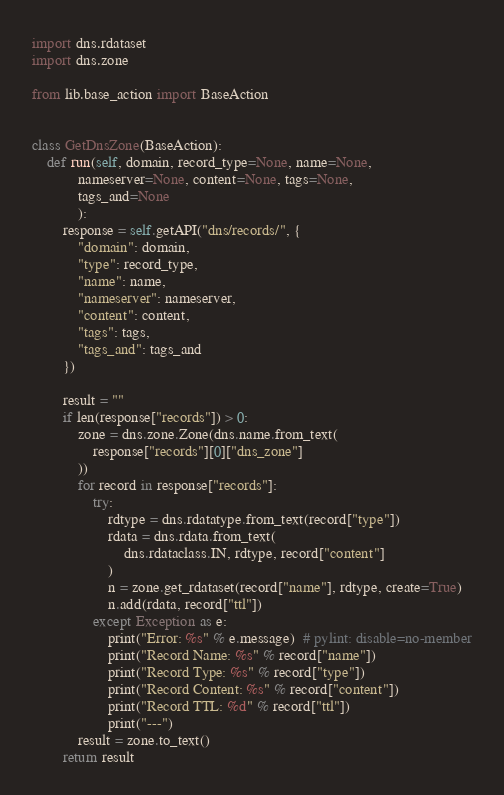Convert code to text. <code><loc_0><loc_0><loc_500><loc_500><_Python_>import dns.rdataset
import dns.zone

from lib.base_action import BaseAction


class GetDnsZone(BaseAction):
    def run(self, domain, record_type=None, name=None,
            nameserver=None, content=None, tags=None,
            tags_and=None
            ):
        response = self.getAPI("dns/records/", {
            "domain": domain,
            "type": record_type,
            "name": name,
            "nameserver": nameserver,
            "content": content,
            "tags": tags,
            "tags_and": tags_and
        })

        result = ""
        if len(response["records"]) > 0:
            zone = dns.zone.Zone(dns.name.from_text(
                response["records"][0]["dns_zone"]
            ))
            for record in response["records"]:
                try:
                    rdtype = dns.rdatatype.from_text(record["type"])
                    rdata = dns.rdata.from_text(
                        dns.rdataclass.IN, rdtype, record["content"]
                    )
                    n = zone.get_rdataset(record["name"], rdtype, create=True)
                    n.add(rdata, record["ttl"])
                except Exception as e:
                    print("Error: %s" % e.message)  # pylint: disable=no-member
                    print("Record Name: %s" % record["name"])
                    print("Record Type: %s" % record["type"])
                    print("Record Content: %s" % record["content"])
                    print("Record TTL: %d" % record["ttl"])
                    print("---")
            result = zone.to_text()
        return result
</code> 